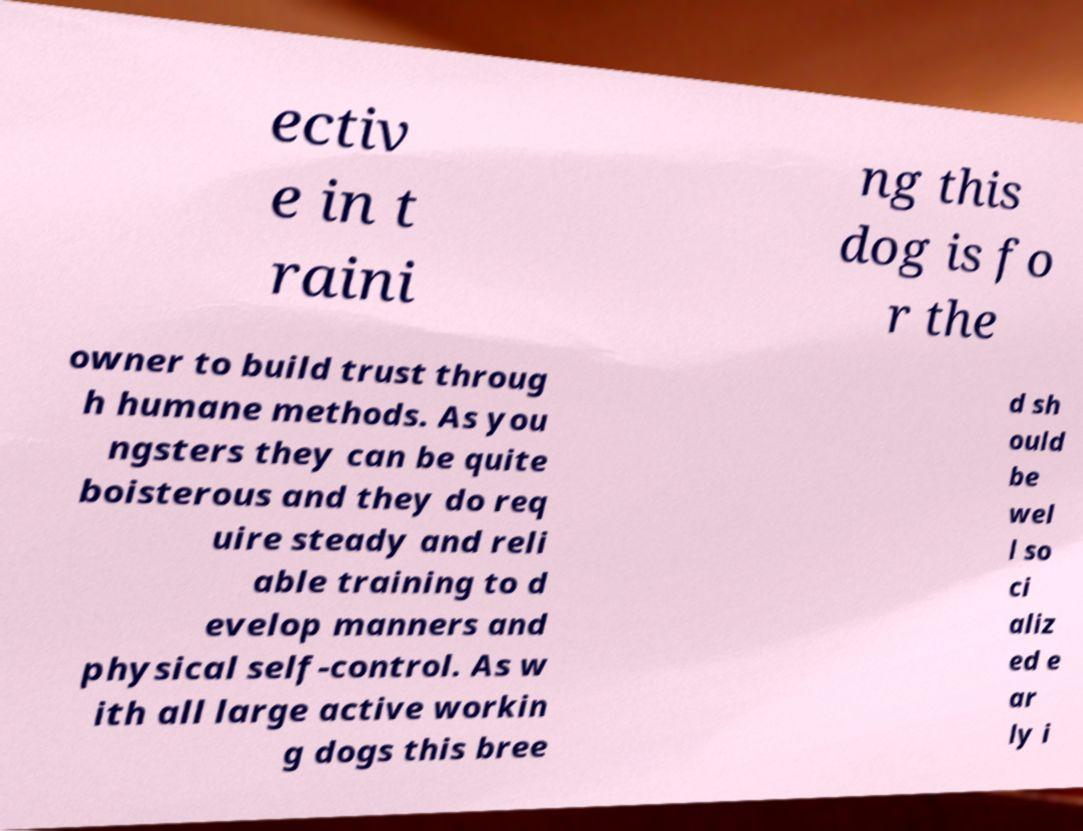There's text embedded in this image that I need extracted. Can you transcribe it verbatim? ectiv e in t raini ng this dog is fo r the owner to build trust throug h humane methods. As you ngsters they can be quite boisterous and they do req uire steady and reli able training to d evelop manners and physical self-control. As w ith all large active workin g dogs this bree d sh ould be wel l so ci aliz ed e ar ly i 